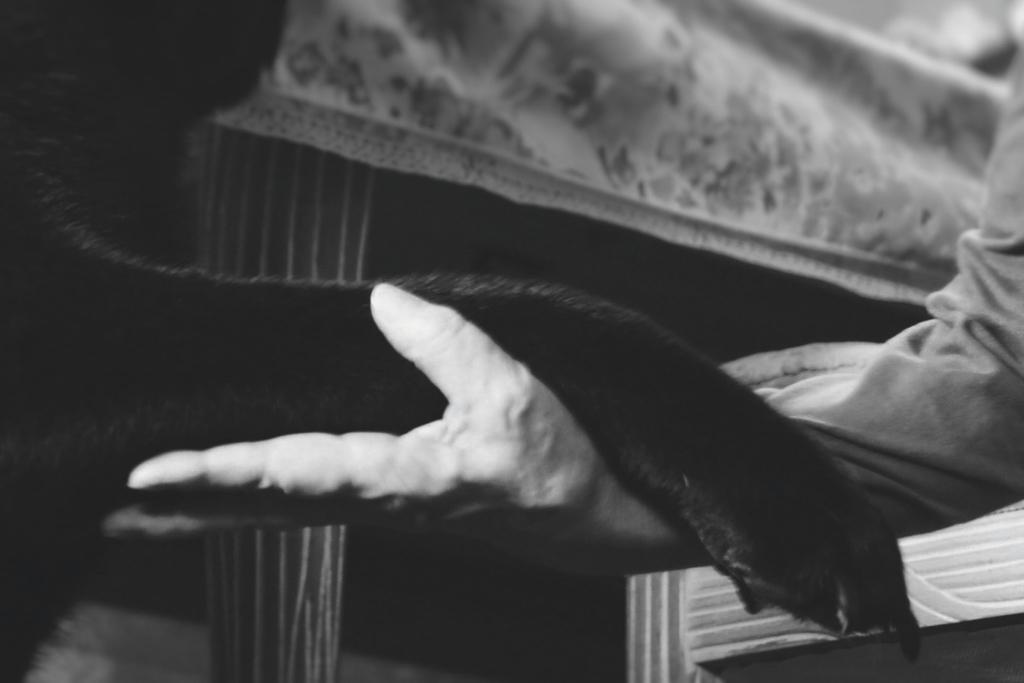What is the color scheme of the image? The image is black and white. What is the person in the image doing? The person is holding an animal's leg in the image. What can be seen in the background of the image? There is a table in the background of the image. What type of game is being played with the bubble in the image? There is no game or bubble present in the image. How many ants can be seen crawling on the table in the image? There are no ants visible in the image; it only shows a person holding an animal's leg and a table in the background. 